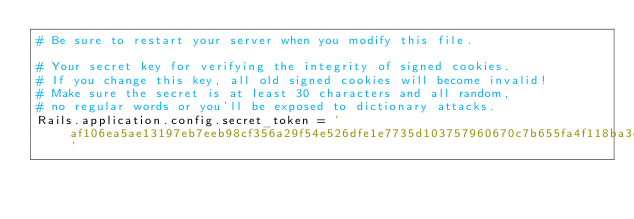<code> <loc_0><loc_0><loc_500><loc_500><_Ruby_># Be sure to restart your server when you modify this file.

# Your secret key for verifying the integrity of signed cookies.
# If you change this key, all old signed cookies will become invalid!
# Make sure the secret is at least 30 characters and all random, 
# no regular words or you'll be exposed to dictionary attacks.
Rails.application.config.secret_token = 'af106ea5ae13197eb7eeb98cf356a29f54e526dfe1e7735d103757960670c7b655fa4f118ba3c909808d1c25bbd3f0cb8f72170f34fe6a912c073bfd4a301c30'
</code> 